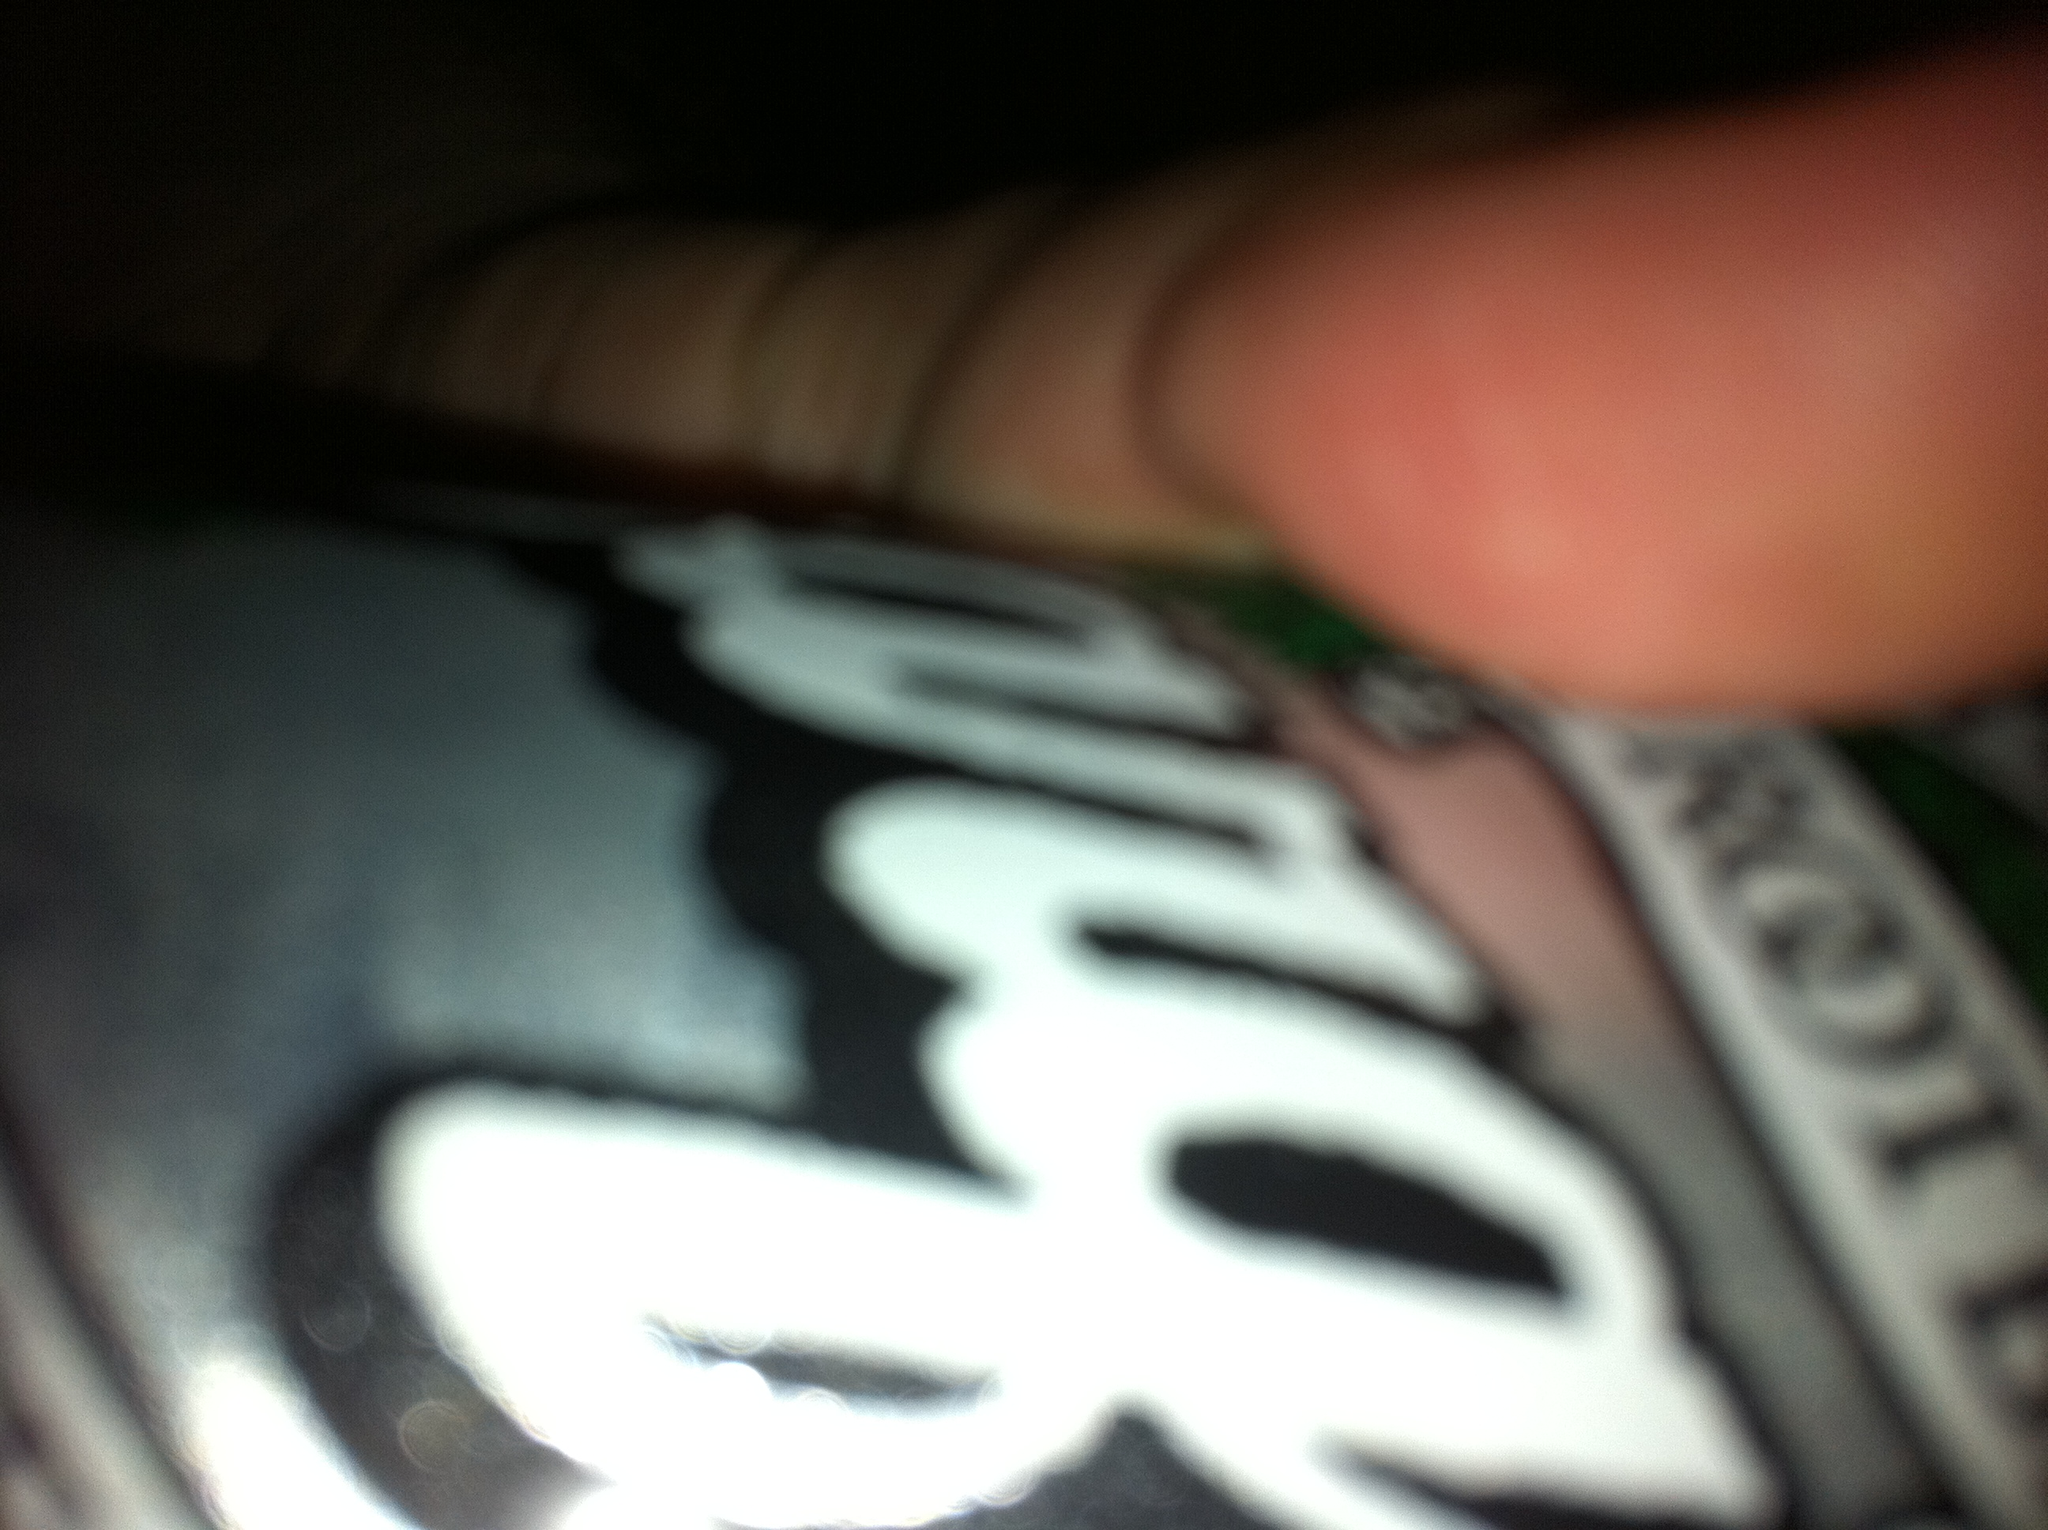What soda is this? The soda in the image appears to be root beer, based on the visible part of the label. 